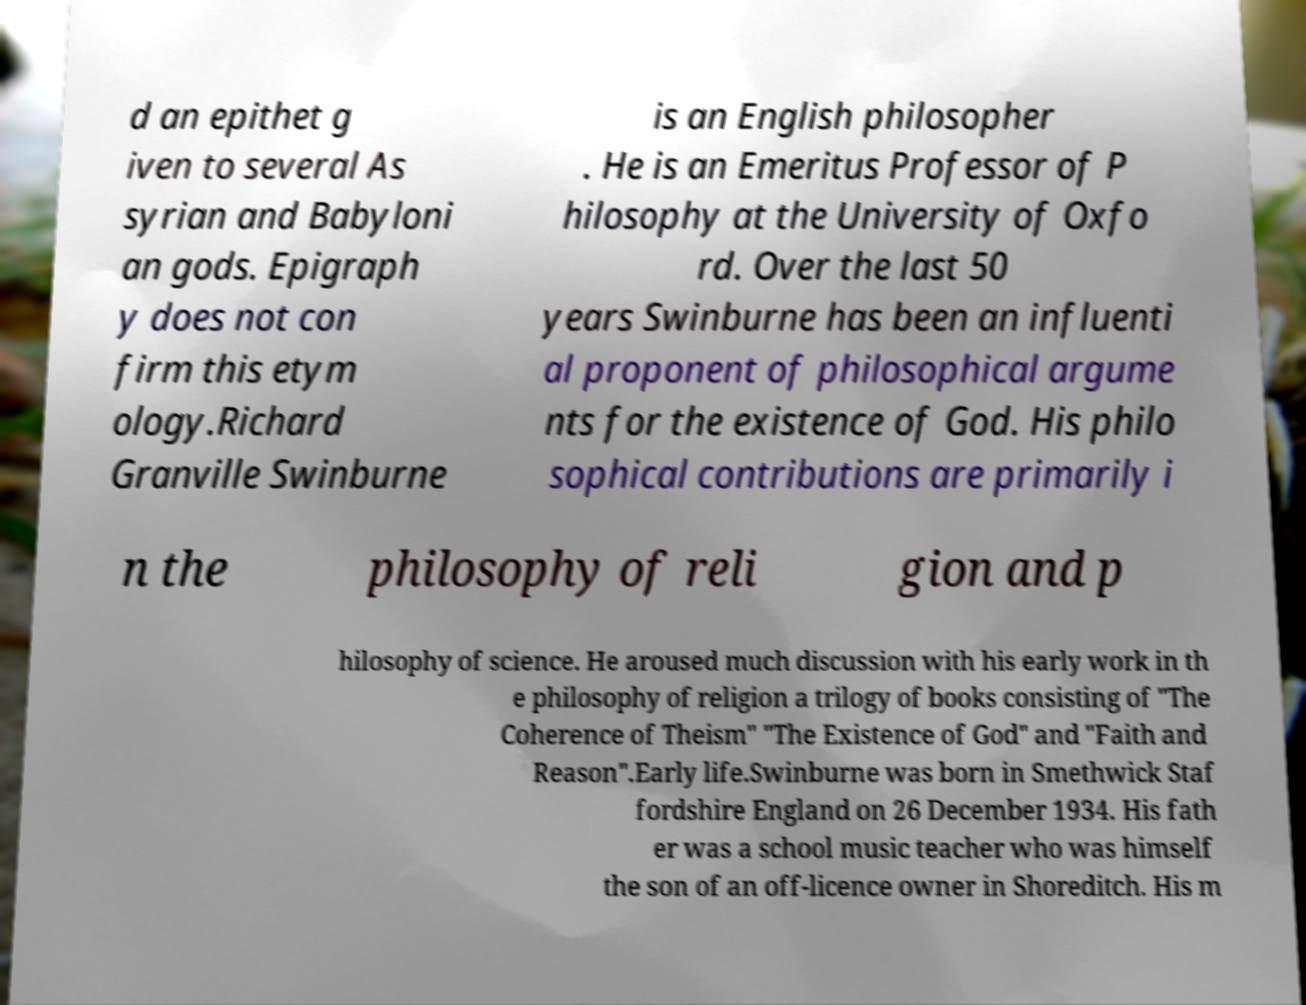Can you accurately transcribe the text from the provided image for me? d an epithet g iven to several As syrian and Babyloni an gods. Epigraph y does not con firm this etym ology.Richard Granville Swinburne is an English philosopher . He is an Emeritus Professor of P hilosophy at the University of Oxfo rd. Over the last 50 years Swinburne has been an influenti al proponent of philosophical argume nts for the existence of God. His philo sophical contributions are primarily i n the philosophy of reli gion and p hilosophy of science. He aroused much discussion with his early work in th e philosophy of religion a trilogy of books consisting of "The Coherence of Theism" "The Existence of God" and "Faith and Reason".Early life.Swinburne was born in Smethwick Staf fordshire England on 26 December 1934. His fath er was a school music teacher who was himself the son of an off-licence owner in Shoreditch. His m 